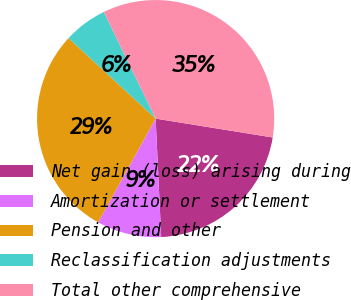Convert chart to OTSL. <chart><loc_0><loc_0><loc_500><loc_500><pie_chart><fcel>Net gain (loss) arising during<fcel>Amortization or settlement<fcel>Pension and other<fcel>Reclassification adjustments<fcel>Total other comprehensive<nl><fcel>21.71%<fcel>8.81%<fcel>28.81%<fcel>5.93%<fcel>34.74%<nl></chart> 